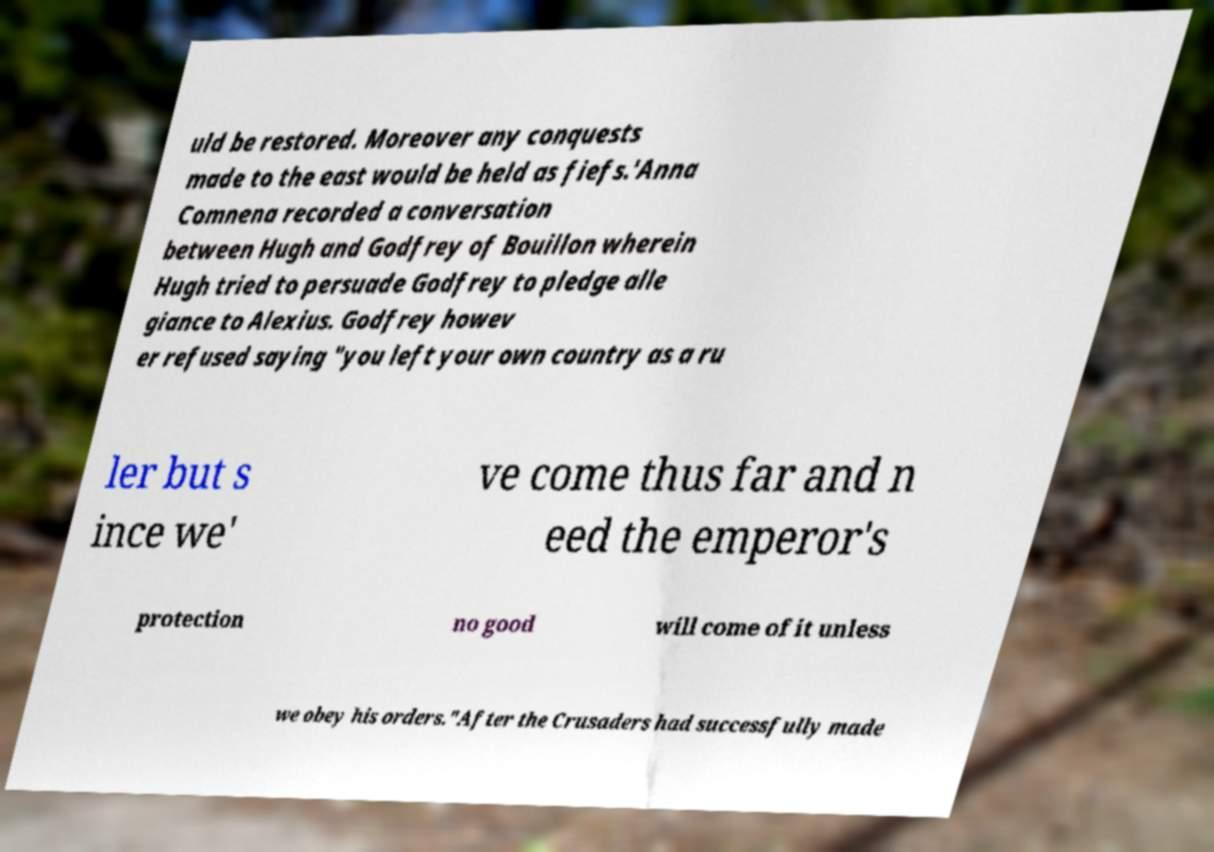Please read and relay the text visible in this image. What does it say? uld be restored. Moreover any conquests made to the east would be held as fiefs.'Anna Comnena recorded a conversation between Hugh and Godfrey of Bouillon wherein Hugh tried to persuade Godfrey to pledge alle giance to Alexius. Godfrey howev er refused saying "you left your own country as a ru ler but s ince we' ve come thus far and n eed the emperor's protection no good will come of it unless we obey his orders."After the Crusaders had successfully made 